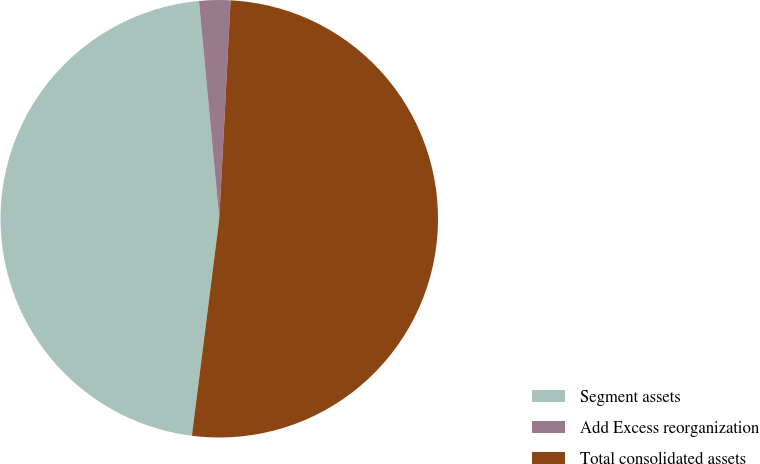<chart> <loc_0><loc_0><loc_500><loc_500><pie_chart><fcel>Segment assets<fcel>Add Excess reorganization<fcel>Total consolidated assets<nl><fcel>46.52%<fcel>2.31%<fcel>51.17%<nl></chart> 